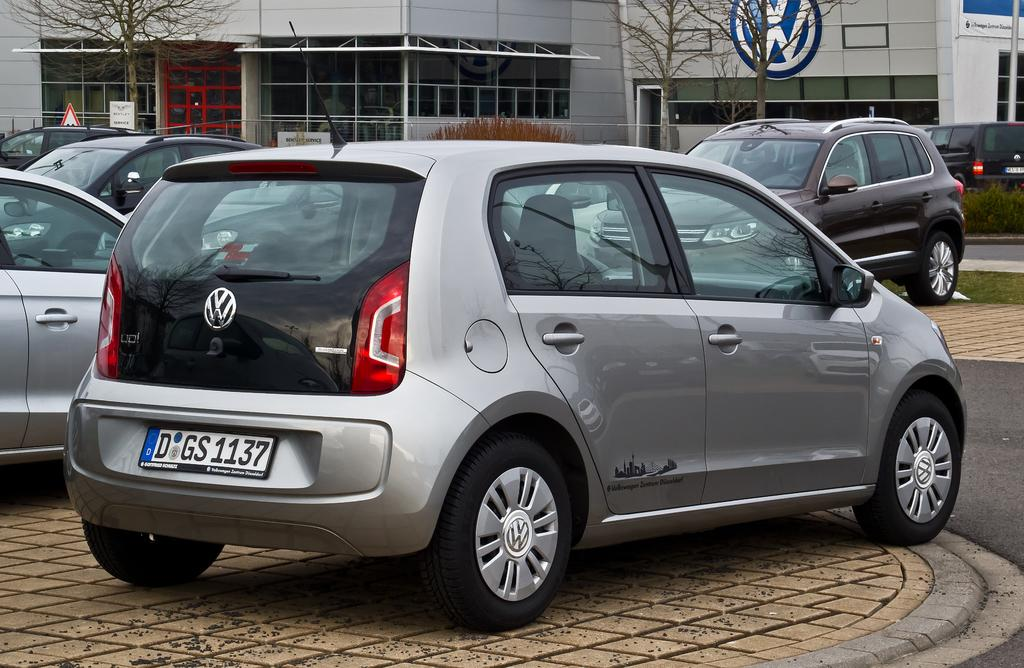What type of vehicles can be seen in the image? There are cars in the image. What structures are present in the image? There are buildings in the image. What type of vegetation is visible in the image? There are dry trees in the image. What type of decorations or signs are present in the image? There are banners in the image. What architectural features can be seen in the image? There are windows in the image. What type of natural elements are present in the image? There are plants in the image. How does the image show an increase in the number of visitors? The image does not show an increase in the number of visitors; it only depicts cars, buildings, dry trees, banners, windows, and plants. What type of twig can be seen in the image? There is no twig present in the image. 